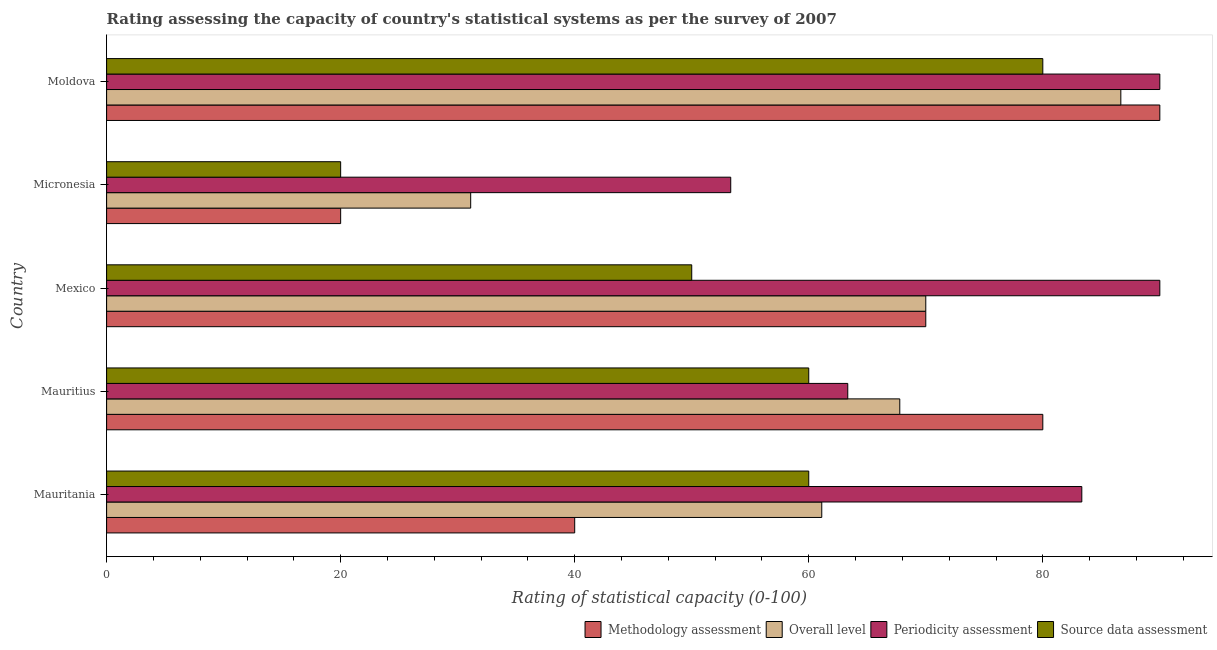Are the number of bars per tick equal to the number of legend labels?
Your response must be concise. Yes. How many bars are there on the 4th tick from the top?
Provide a succinct answer. 4. How many bars are there on the 2nd tick from the bottom?
Ensure brevity in your answer.  4. What is the label of the 3rd group of bars from the top?
Make the answer very short. Mexico. In how many cases, is the number of bars for a given country not equal to the number of legend labels?
Keep it short and to the point. 0. What is the source data assessment rating in Mauritania?
Offer a terse response. 60. Across all countries, what is the maximum overall level rating?
Offer a very short reply. 86.67. Across all countries, what is the minimum overall level rating?
Give a very brief answer. 31.11. In which country was the methodology assessment rating minimum?
Give a very brief answer. Micronesia. What is the total overall level rating in the graph?
Provide a succinct answer. 316.67. What is the difference between the methodology assessment rating in Mexico and that in Moldova?
Ensure brevity in your answer.  -20. What is the difference between the overall level rating in Mexico and the methodology assessment rating in Mauritania?
Provide a succinct answer. 30. What is the average methodology assessment rating per country?
Keep it short and to the point. 60. What is the difference between the periodicity assessment rating and methodology assessment rating in Micronesia?
Provide a succinct answer. 33.33. In how many countries, is the overall level rating greater than 40 ?
Your response must be concise. 4. What is the ratio of the overall level rating in Mauritius to that in Moldova?
Your response must be concise. 0.78. Is the periodicity assessment rating in Mauritania less than that in Micronesia?
Give a very brief answer. No. What is the difference between the highest and the second highest methodology assessment rating?
Ensure brevity in your answer.  10. What is the difference between the highest and the lowest periodicity assessment rating?
Give a very brief answer. 36.67. Is the sum of the methodology assessment rating in Mexico and Micronesia greater than the maximum periodicity assessment rating across all countries?
Make the answer very short. No. Is it the case that in every country, the sum of the methodology assessment rating and periodicity assessment rating is greater than the sum of overall level rating and source data assessment rating?
Provide a succinct answer. No. What does the 2nd bar from the top in Moldova represents?
Offer a terse response. Periodicity assessment. What does the 2nd bar from the bottom in Moldova represents?
Keep it short and to the point. Overall level. How many bars are there?
Offer a terse response. 20. Are all the bars in the graph horizontal?
Your answer should be compact. Yes. What is the difference between two consecutive major ticks on the X-axis?
Offer a terse response. 20. Are the values on the major ticks of X-axis written in scientific E-notation?
Your answer should be very brief. No. Does the graph contain any zero values?
Your answer should be compact. No. Does the graph contain grids?
Your answer should be very brief. No. Where does the legend appear in the graph?
Provide a short and direct response. Bottom right. How many legend labels are there?
Provide a short and direct response. 4. What is the title of the graph?
Your response must be concise. Rating assessing the capacity of country's statistical systems as per the survey of 2007 . Does "Australia" appear as one of the legend labels in the graph?
Keep it short and to the point. No. What is the label or title of the X-axis?
Give a very brief answer. Rating of statistical capacity (0-100). What is the Rating of statistical capacity (0-100) in Methodology assessment in Mauritania?
Give a very brief answer. 40. What is the Rating of statistical capacity (0-100) in Overall level in Mauritania?
Provide a short and direct response. 61.11. What is the Rating of statistical capacity (0-100) of Periodicity assessment in Mauritania?
Ensure brevity in your answer.  83.33. What is the Rating of statistical capacity (0-100) of Methodology assessment in Mauritius?
Your answer should be very brief. 80. What is the Rating of statistical capacity (0-100) in Overall level in Mauritius?
Make the answer very short. 67.78. What is the Rating of statistical capacity (0-100) in Periodicity assessment in Mauritius?
Ensure brevity in your answer.  63.33. What is the Rating of statistical capacity (0-100) in Methodology assessment in Mexico?
Your response must be concise. 70. What is the Rating of statistical capacity (0-100) in Overall level in Mexico?
Provide a succinct answer. 70. What is the Rating of statistical capacity (0-100) of Periodicity assessment in Mexico?
Your response must be concise. 90. What is the Rating of statistical capacity (0-100) in Overall level in Micronesia?
Offer a terse response. 31.11. What is the Rating of statistical capacity (0-100) of Periodicity assessment in Micronesia?
Your answer should be compact. 53.33. What is the Rating of statistical capacity (0-100) in Source data assessment in Micronesia?
Your answer should be very brief. 20. What is the Rating of statistical capacity (0-100) of Overall level in Moldova?
Make the answer very short. 86.67. Across all countries, what is the maximum Rating of statistical capacity (0-100) in Methodology assessment?
Provide a succinct answer. 90. Across all countries, what is the maximum Rating of statistical capacity (0-100) of Overall level?
Your answer should be compact. 86.67. Across all countries, what is the minimum Rating of statistical capacity (0-100) of Methodology assessment?
Offer a very short reply. 20. Across all countries, what is the minimum Rating of statistical capacity (0-100) in Overall level?
Offer a terse response. 31.11. Across all countries, what is the minimum Rating of statistical capacity (0-100) of Periodicity assessment?
Provide a short and direct response. 53.33. What is the total Rating of statistical capacity (0-100) in Methodology assessment in the graph?
Your answer should be compact. 300. What is the total Rating of statistical capacity (0-100) of Overall level in the graph?
Your answer should be very brief. 316.67. What is the total Rating of statistical capacity (0-100) of Periodicity assessment in the graph?
Your answer should be very brief. 380. What is the total Rating of statistical capacity (0-100) of Source data assessment in the graph?
Give a very brief answer. 270. What is the difference between the Rating of statistical capacity (0-100) in Methodology assessment in Mauritania and that in Mauritius?
Ensure brevity in your answer.  -40. What is the difference between the Rating of statistical capacity (0-100) in Overall level in Mauritania and that in Mauritius?
Provide a short and direct response. -6.67. What is the difference between the Rating of statistical capacity (0-100) of Overall level in Mauritania and that in Mexico?
Offer a terse response. -8.89. What is the difference between the Rating of statistical capacity (0-100) of Periodicity assessment in Mauritania and that in Mexico?
Offer a very short reply. -6.67. What is the difference between the Rating of statistical capacity (0-100) of Source data assessment in Mauritania and that in Mexico?
Your response must be concise. 10. What is the difference between the Rating of statistical capacity (0-100) in Methodology assessment in Mauritania and that in Micronesia?
Make the answer very short. 20. What is the difference between the Rating of statistical capacity (0-100) in Source data assessment in Mauritania and that in Micronesia?
Provide a succinct answer. 40. What is the difference between the Rating of statistical capacity (0-100) in Methodology assessment in Mauritania and that in Moldova?
Your answer should be compact. -50. What is the difference between the Rating of statistical capacity (0-100) of Overall level in Mauritania and that in Moldova?
Make the answer very short. -25.56. What is the difference between the Rating of statistical capacity (0-100) in Periodicity assessment in Mauritania and that in Moldova?
Offer a terse response. -6.67. What is the difference between the Rating of statistical capacity (0-100) in Overall level in Mauritius and that in Mexico?
Make the answer very short. -2.22. What is the difference between the Rating of statistical capacity (0-100) of Periodicity assessment in Mauritius and that in Mexico?
Your response must be concise. -26.67. What is the difference between the Rating of statistical capacity (0-100) of Source data assessment in Mauritius and that in Mexico?
Make the answer very short. 10. What is the difference between the Rating of statistical capacity (0-100) in Overall level in Mauritius and that in Micronesia?
Ensure brevity in your answer.  36.67. What is the difference between the Rating of statistical capacity (0-100) of Periodicity assessment in Mauritius and that in Micronesia?
Your answer should be compact. 10. What is the difference between the Rating of statistical capacity (0-100) of Methodology assessment in Mauritius and that in Moldova?
Provide a succinct answer. -10. What is the difference between the Rating of statistical capacity (0-100) in Overall level in Mauritius and that in Moldova?
Ensure brevity in your answer.  -18.89. What is the difference between the Rating of statistical capacity (0-100) in Periodicity assessment in Mauritius and that in Moldova?
Provide a succinct answer. -26.67. What is the difference between the Rating of statistical capacity (0-100) of Source data assessment in Mauritius and that in Moldova?
Provide a short and direct response. -20. What is the difference between the Rating of statistical capacity (0-100) in Methodology assessment in Mexico and that in Micronesia?
Provide a short and direct response. 50. What is the difference between the Rating of statistical capacity (0-100) of Overall level in Mexico and that in Micronesia?
Your answer should be very brief. 38.89. What is the difference between the Rating of statistical capacity (0-100) of Periodicity assessment in Mexico and that in Micronesia?
Provide a succinct answer. 36.67. What is the difference between the Rating of statistical capacity (0-100) of Source data assessment in Mexico and that in Micronesia?
Keep it short and to the point. 30. What is the difference between the Rating of statistical capacity (0-100) in Methodology assessment in Mexico and that in Moldova?
Provide a short and direct response. -20. What is the difference between the Rating of statistical capacity (0-100) in Overall level in Mexico and that in Moldova?
Your response must be concise. -16.67. What is the difference between the Rating of statistical capacity (0-100) in Periodicity assessment in Mexico and that in Moldova?
Ensure brevity in your answer.  0. What is the difference between the Rating of statistical capacity (0-100) of Source data assessment in Mexico and that in Moldova?
Provide a succinct answer. -30. What is the difference between the Rating of statistical capacity (0-100) of Methodology assessment in Micronesia and that in Moldova?
Keep it short and to the point. -70. What is the difference between the Rating of statistical capacity (0-100) in Overall level in Micronesia and that in Moldova?
Offer a very short reply. -55.56. What is the difference between the Rating of statistical capacity (0-100) in Periodicity assessment in Micronesia and that in Moldova?
Your answer should be compact. -36.67. What is the difference between the Rating of statistical capacity (0-100) of Source data assessment in Micronesia and that in Moldova?
Your response must be concise. -60. What is the difference between the Rating of statistical capacity (0-100) in Methodology assessment in Mauritania and the Rating of statistical capacity (0-100) in Overall level in Mauritius?
Ensure brevity in your answer.  -27.78. What is the difference between the Rating of statistical capacity (0-100) in Methodology assessment in Mauritania and the Rating of statistical capacity (0-100) in Periodicity assessment in Mauritius?
Offer a terse response. -23.33. What is the difference between the Rating of statistical capacity (0-100) in Overall level in Mauritania and the Rating of statistical capacity (0-100) in Periodicity assessment in Mauritius?
Your response must be concise. -2.22. What is the difference between the Rating of statistical capacity (0-100) in Overall level in Mauritania and the Rating of statistical capacity (0-100) in Source data assessment in Mauritius?
Offer a terse response. 1.11. What is the difference between the Rating of statistical capacity (0-100) of Periodicity assessment in Mauritania and the Rating of statistical capacity (0-100) of Source data assessment in Mauritius?
Provide a short and direct response. 23.33. What is the difference between the Rating of statistical capacity (0-100) in Overall level in Mauritania and the Rating of statistical capacity (0-100) in Periodicity assessment in Mexico?
Your answer should be very brief. -28.89. What is the difference between the Rating of statistical capacity (0-100) in Overall level in Mauritania and the Rating of statistical capacity (0-100) in Source data assessment in Mexico?
Keep it short and to the point. 11.11. What is the difference between the Rating of statistical capacity (0-100) of Periodicity assessment in Mauritania and the Rating of statistical capacity (0-100) of Source data assessment in Mexico?
Provide a short and direct response. 33.33. What is the difference between the Rating of statistical capacity (0-100) of Methodology assessment in Mauritania and the Rating of statistical capacity (0-100) of Overall level in Micronesia?
Your answer should be compact. 8.89. What is the difference between the Rating of statistical capacity (0-100) in Methodology assessment in Mauritania and the Rating of statistical capacity (0-100) in Periodicity assessment in Micronesia?
Your response must be concise. -13.33. What is the difference between the Rating of statistical capacity (0-100) in Overall level in Mauritania and the Rating of statistical capacity (0-100) in Periodicity assessment in Micronesia?
Provide a succinct answer. 7.78. What is the difference between the Rating of statistical capacity (0-100) of Overall level in Mauritania and the Rating of statistical capacity (0-100) of Source data assessment in Micronesia?
Give a very brief answer. 41.11. What is the difference between the Rating of statistical capacity (0-100) of Periodicity assessment in Mauritania and the Rating of statistical capacity (0-100) of Source data assessment in Micronesia?
Give a very brief answer. 63.33. What is the difference between the Rating of statistical capacity (0-100) of Methodology assessment in Mauritania and the Rating of statistical capacity (0-100) of Overall level in Moldova?
Offer a terse response. -46.67. What is the difference between the Rating of statistical capacity (0-100) of Methodology assessment in Mauritania and the Rating of statistical capacity (0-100) of Periodicity assessment in Moldova?
Offer a very short reply. -50. What is the difference between the Rating of statistical capacity (0-100) of Overall level in Mauritania and the Rating of statistical capacity (0-100) of Periodicity assessment in Moldova?
Offer a very short reply. -28.89. What is the difference between the Rating of statistical capacity (0-100) of Overall level in Mauritania and the Rating of statistical capacity (0-100) of Source data assessment in Moldova?
Make the answer very short. -18.89. What is the difference between the Rating of statistical capacity (0-100) in Periodicity assessment in Mauritania and the Rating of statistical capacity (0-100) in Source data assessment in Moldova?
Make the answer very short. 3.33. What is the difference between the Rating of statistical capacity (0-100) in Methodology assessment in Mauritius and the Rating of statistical capacity (0-100) in Overall level in Mexico?
Your answer should be compact. 10. What is the difference between the Rating of statistical capacity (0-100) of Methodology assessment in Mauritius and the Rating of statistical capacity (0-100) of Periodicity assessment in Mexico?
Provide a short and direct response. -10. What is the difference between the Rating of statistical capacity (0-100) of Methodology assessment in Mauritius and the Rating of statistical capacity (0-100) of Source data assessment in Mexico?
Make the answer very short. 30. What is the difference between the Rating of statistical capacity (0-100) of Overall level in Mauritius and the Rating of statistical capacity (0-100) of Periodicity assessment in Mexico?
Your answer should be compact. -22.22. What is the difference between the Rating of statistical capacity (0-100) of Overall level in Mauritius and the Rating of statistical capacity (0-100) of Source data assessment in Mexico?
Keep it short and to the point. 17.78. What is the difference between the Rating of statistical capacity (0-100) of Periodicity assessment in Mauritius and the Rating of statistical capacity (0-100) of Source data assessment in Mexico?
Your answer should be very brief. 13.33. What is the difference between the Rating of statistical capacity (0-100) in Methodology assessment in Mauritius and the Rating of statistical capacity (0-100) in Overall level in Micronesia?
Give a very brief answer. 48.89. What is the difference between the Rating of statistical capacity (0-100) of Methodology assessment in Mauritius and the Rating of statistical capacity (0-100) of Periodicity assessment in Micronesia?
Your answer should be very brief. 26.67. What is the difference between the Rating of statistical capacity (0-100) of Overall level in Mauritius and the Rating of statistical capacity (0-100) of Periodicity assessment in Micronesia?
Provide a succinct answer. 14.44. What is the difference between the Rating of statistical capacity (0-100) of Overall level in Mauritius and the Rating of statistical capacity (0-100) of Source data assessment in Micronesia?
Keep it short and to the point. 47.78. What is the difference between the Rating of statistical capacity (0-100) of Periodicity assessment in Mauritius and the Rating of statistical capacity (0-100) of Source data assessment in Micronesia?
Ensure brevity in your answer.  43.33. What is the difference between the Rating of statistical capacity (0-100) in Methodology assessment in Mauritius and the Rating of statistical capacity (0-100) in Overall level in Moldova?
Provide a succinct answer. -6.67. What is the difference between the Rating of statistical capacity (0-100) in Methodology assessment in Mauritius and the Rating of statistical capacity (0-100) in Periodicity assessment in Moldova?
Make the answer very short. -10. What is the difference between the Rating of statistical capacity (0-100) of Methodology assessment in Mauritius and the Rating of statistical capacity (0-100) of Source data assessment in Moldova?
Your response must be concise. 0. What is the difference between the Rating of statistical capacity (0-100) of Overall level in Mauritius and the Rating of statistical capacity (0-100) of Periodicity assessment in Moldova?
Offer a terse response. -22.22. What is the difference between the Rating of statistical capacity (0-100) in Overall level in Mauritius and the Rating of statistical capacity (0-100) in Source data assessment in Moldova?
Make the answer very short. -12.22. What is the difference between the Rating of statistical capacity (0-100) in Periodicity assessment in Mauritius and the Rating of statistical capacity (0-100) in Source data assessment in Moldova?
Give a very brief answer. -16.67. What is the difference between the Rating of statistical capacity (0-100) in Methodology assessment in Mexico and the Rating of statistical capacity (0-100) in Overall level in Micronesia?
Your answer should be very brief. 38.89. What is the difference between the Rating of statistical capacity (0-100) in Methodology assessment in Mexico and the Rating of statistical capacity (0-100) in Periodicity assessment in Micronesia?
Your answer should be compact. 16.67. What is the difference between the Rating of statistical capacity (0-100) in Overall level in Mexico and the Rating of statistical capacity (0-100) in Periodicity assessment in Micronesia?
Provide a short and direct response. 16.67. What is the difference between the Rating of statistical capacity (0-100) of Methodology assessment in Mexico and the Rating of statistical capacity (0-100) of Overall level in Moldova?
Offer a terse response. -16.67. What is the difference between the Rating of statistical capacity (0-100) of Periodicity assessment in Mexico and the Rating of statistical capacity (0-100) of Source data assessment in Moldova?
Ensure brevity in your answer.  10. What is the difference between the Rating of statistical capacity (0-100) of Methodology assessment in Micronesia and the Rating of statistical capacity (0-100) of Overall level in Moldova?
Give a very brief answer. -66.67. What is the difference between the Rating of statistical capacity (0-100) of Methodology assessment in Micronesia and the Rating of statistical capacity (0-100) of Periodicity assessment in Moldova?
Make the answer very short. -70. What is the difference between the Rating of statistical capacity (0-100) of Methodology assessment in Micronesia and the Rating of statistical capacity (0-100) of Source data assessment in Moldova?
Offer a terse response. -60. What is the difference between the Rating of statistical capacity (0-100) of Overall level in Micronesia and the Rating of statistical capacity (0-100) of Periodicity assessment in Moldova?
Make the answer very short. -58.89. What is the difference between the Rating of statistical capacity (0-100) of Overall level in Micronesia and the Rating of statistical capacity (0-100) of Source data assessment in Moldova?
Provide a short and direct response. -48.89. What is the difference between the Rating of statistical capacity (0-100) in Periodicity assessment in Micronesia and the Rating of statistical capacity (0-100) in Source data assessment in Moldova?
Your answer should be compact. -26.67. What is the average Rating of statistical capacity (0-100) in Methodology assessment per country?
Offer a terse response. 60. What is the average Rating of statistical capacity (0-100) in Overall level per country?
Make the answer very short. 63.33. What is the average Rating of statistical capacity (0-100) of Source data assessment per country?
Make the answer very short. 54. What is the difference between the Rating of statistical capacity (0-100) of Methodology assessment and Rating of statistical capacity (0-100) of Overall level in Mauritania?
Your answer should be compact. -21.11. What is the difference between the Rating of statistical capacity (0-100) of Methodology assessment and Rating of statistical capacity (0-100) of Periodicity assessment in Mauritania?
Your answer should be very brief. -43.33. What is the difference between the Rating of statistical capacity (0-100) in Methodology assessment and Rating of statistical capacity (0-100) in Source data assessment in Mauritania?
Provide a succinct answer. -20. What is the difference between the Rating of statistical capacity (0-100) of Overall level and Rating of statistical capacity (0-100) of Periodicity assessment in Mauritania?
Offer a terse response. -22.22. What is the difference between the Rating of statistical capacity (0-100) in Periodicity assessment and Rating of statistical capacity (0-100) in Source data assessment in Mauritania?
Offer a very short reply. 23.33. What is the difference between the Rating of statistical capacity (0-100) in Methodology assessment and Rating of statistical capacity (0-100) in Overall level in Mauritius?
Give a very brief answer. 12.22. What is the difference between the Rating of statistical capacity (0-100) in Methodology assessment and Rating of statistical capacity (0-100) in Periodicity assessment in Mauritius?
Provide a succinct answer. 16.67. What is the difference between the Rating of statistical capacity (0-100) of Overall level and Rating of statistical capacity (0-100) of Periodicity assessment in Mauritius?
Provide a succinct answer. 4.44. What is the difference between the Rating of statistical capacity (0-100) of Overall level and Rating of statistical capacity (0-100) of Source data assessment in Mauritius?
Your response must be concise. 7.78. What is the difference between the Rating of statistical capacity (0-100) of Periodicity assessment and Rating of statistical capacity (0-100) of Source data assessment in Mauritius?
Your answer should be compact. 3.33. What is the difference between the Rating of statistical capacity (0-100) of Methodology assessment and Rating of statistical capacity (0-100) of Overall level in Mexico?
Give a very brief answer. 0. What is the difference between the Rating of statistical capacity (0-100) of Overall level and Rating of statistical capacity (0-100) of Source data assessment in Mexico?
Keep it short and to the point. 20. What is the difference between the Rating of statistical capacity (0-100) of Methodology assessment and Rating of statistical capacity (0-100) of Overall level in Micronesia?
Offer a terse response. -11.11. What is the difference between the Rating of statistical capacity (0-100) in Methodology assessment and Rating of statistical capacity (0-100) in Periodicity assessment in Micronesia?
Your answer should be very brief. -33.33. What is the difference between the Rating of statistical capacity (0-100) of Methodology assessment and Rating of statistical capacity (0-100) of Source data assessment in Micronesia?
Make the answer very short. 0. What is the difference between the Rating of statistical capacity (0-100) of Overall level and Rating of statistical capacity (0-100) of Periodicity assessment in Micronesia?
Your answer should be compact. -22.22. What is the difference between the Rating of statistical capacity (0-100) of Overall level and Rating of statistical capacity (0-100) of Source data assessment in Micronesia?
Provide a succinct answer. 11.11. What is the difference between the Rating of statistical capacity (0-100) in Periodicity assessment and Rating of statistical capacity (0-100) in Source data assessment in Micronesia?
Your response must be concise. 33.33. What is the difference between the Rating of statistical capacity (0-100) in Methodology assessment and Rating of statistical capacity (0-100) in Source data assessment in Moldova?
Keep it short and to the point. 10. What is the difference between the Rating of statistical capacity (0-100) of Overall level and Rating of statistical capacity (0-100) of Periodicity assessment in Moldova?
Offer a very short reply. -3.33. What is the difference between the Rating of statistical capacity (0-100) of Overall level and Rating of statistical capacity (0-100) of Source data assessment in Moldova?
Give a very brief answer. 6.67. What is the difference between the Rating of statistical capacity (0-100) in Periodicity assessment and Rating of statistical capacity (0-100) in Source data assessment in Moldova?
Your answer should be very brief. 10. What is the ratio of the Rating of statistical capacity (0-100) of Overall level in Mauritania to that in Mauritius?
Make the answer very short. 0.9. What is the ratio of the Rating of statistical capacity (0-100) of Periodicity assessment in Mauritania to that in Mauritius?
Ensure brevity in your answer.  1.32. What is the ratio of the Rating of statistical capacity (0-100) of Source data assessment in Mauritania to that in Mauritius?
Provide a succinct answer. 1. What is the ratio of the Rating of statistical capacity (0-100) of Methodology assessment in Mauritania to that in Mexico?
Offer a terse response. 0.57. What is the ratio of the Rating of statistical capacity (0-100) of Overall level in Mauritania to that in Mexico?
Your response must be concise. 0.87. What is the ratio of the Rating of statistical capacity (0-100) of Periodicity assessment in Mauritania to that in Mexico?
Offer a very short reply. 0.93. What is the ratio of the Rating of statistical capacity (0-100) of Methodology assessment in Mauritania to that in Micronesia?
Give a very brief answer. 2. What is the ratio of the Rating of statistical capacity (0-100) in Overall level in Mauritania to that in Micronesia?
Your answer should be very brief. 1.96. What is the ratio of the Rating of statistical capacity (0-100) of Periodicity assessment in Mauritania to that in Micronesia?
Offer a very short reply. 1.56. What is the ratio of the Rating of statistical capacity (0-100) of Source data assessment in Mauritania to that in Micronesia?
Your response must be concise. 3. What is the ratio of the Rating of statistical capacity (0-100) in Methodology assessment in Mauritania to that in Moldova?
Ensure brevity in your answer.  0.44. What is the ratio of the Rating of statistical capacity (0-100) of Overall level in Mauritania to that in Moldova?
Provide a short and direct response. 0.71. What is the ratio of the Rating of statistical capacity (0-100) of Periodicity assessment in Mauritania to that in Moldova?
Your response must be concise. 0.93. What is the ratio of the Rating of statistical capacity (0-100) in Source data assessment in Mauritania to that in Moldova?
Offer a very short reply. 0.75. What is the ratio of the Rating of statistical capacity (0-100) of Overall level in Mauritius to that in Mexico?
Your response must be concise. 0.97. What is the ratio of the Rating of statistical capacity (0-100) in Periodicity assessment in Mauritius to that in Mexico?
Offer a very short reply. 0.7. What is the ratio of the Rating of statistical capacity (0-100) in Methodology assessment in Mauritius to that in Micronesia?
Your answer should be compact. 4. What is the ratio of the Rating of statistical capacity (0-100) of Overall level in Mauritius to that in Micronesia?
Offer a very short reply. 2.18. What is the ratio of the Rating of statistical capacity (0-100) in Periodicity assessment in Mauritius to that in Micronesia?
Your response must be concise. 1.19. What is the ratio of the Rating of statistical capacity (0-100) in Source data assessment in Mauritius to that in Micronesia?
Offer a terse response. 3. What is the ratio of the Rating of statistical capacity (0-100) of Overall level in Mauritius to that in Moldova?
Your answer should be compact. 0.78. What is the ratio of the Rating of statistical capacity (0-100) in Periodicity assessment in Mauritius to that in Moldova?
Offer a very short reply. 0.7. What is the ratio of the Rating of statistical capacity (0-100) of Methodology assessment in Mexico to that in Micronesia?
Ensure brevity in your answer.  3.5. What is the ratio of the Rating of statistical capacity (0-100) of Overall level in Mexico to that in Micronesia?
Keep it short and to the point. 2.25. What is the ratio of the Rating of statistical capacity (0-100) of Periodicity assessment in Mexico to that in Micronesia?
Offer a terse response. 1.69. What is the ratio of the Rating of statistical capacity (0-100) of Overall level in Mexico to that in Moldova?
Give a very brief answer. 0.81. What is the ratio of the Rating of statistical capacity (0-100) of Periodicity assessment in Mexico to that in Moldova?
Provide a short and direct response. 1. What is the ratio of the Rating of statistical capacity (0-100) of Source data assessment in Mexico to that in Moldova?
Offer a terse response. 0.62. What is the ratio of the Rating of statistical capacity (0-100) of Methodology assessment in Micronesia to that in Moldova?
Give a very brief answer. 0.22. What is the ratio of the Rating of statistical capacity (0-100) in Overall level in Micronesia to that in Moldova?
Offer a terse response. 0.36. What is the ratio of the Rating of statistical capacity (0-100) in Periodicity assessment in Micronesia to that in Moldova?
Keep it short and to the point. 0.59. What is the ratio of the Rating of statistical capacity (0-100) in Source data assessment in Micronesia to that in Moldova?
Give a very brief answer. 0.25. What is the difference between the highest and the second highest Rating of statistical capacity (0-100) of Methodology assessment?
Ensure brevity in your answer.  10. What is the difference between the highest and the second highest Rating of statistical capacity (0-100) in Overall level?
Your response must be concise. 16.67. What is the difference between the highest and the lowest Rating of statistical capacity (0-100) in Methodology assessment?
Make the answer very short. 70. What is the difference between the highest and the lowest Rating of statistical capacity (0-100) of Overall level?
Make the answer very short. 55.56. What is the difference between the highest and the lowest Rating of statistical capacity (0-100) of Periodicity assessment?
Ensure brevity in your answer.  36.67. 